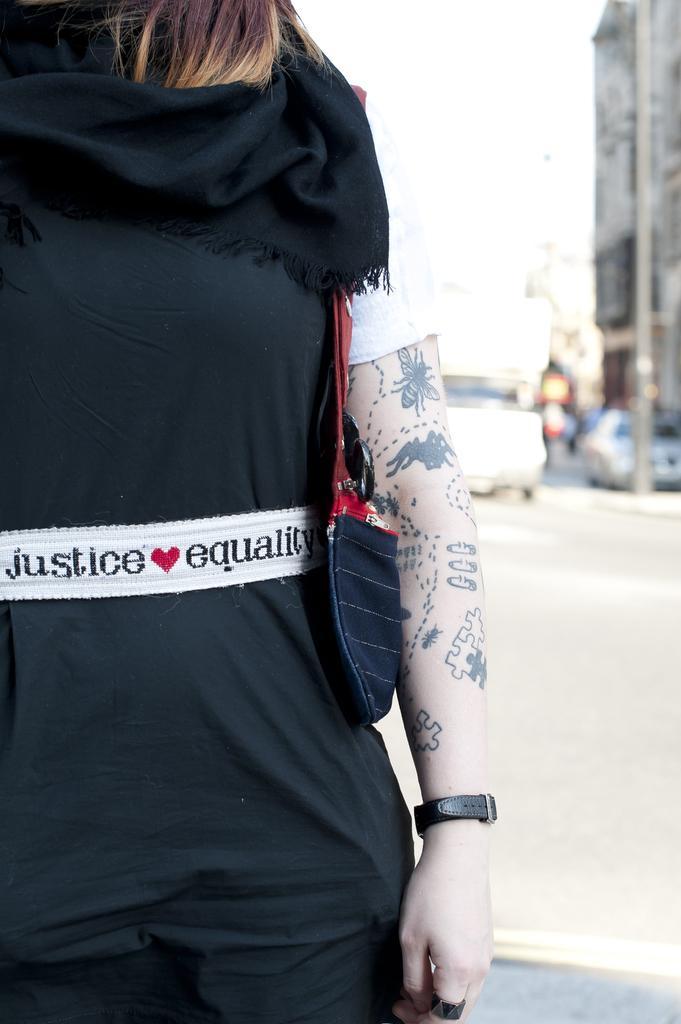In one or two sentences, can you explain what this image depicts? In the foreground I can see a person on the road. In the background I can see vehicles, light pole, buildings and the sky. This image is taken may be during a day. 